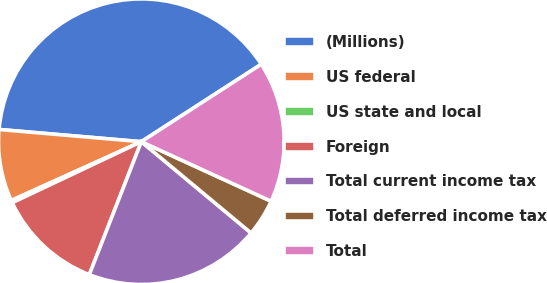<chart> <loc_0><loc_0><loc_500><loc_500><pie_chart><fcel>(Millions)<fcel>US federal<fcel>US state and local<fcel>Foreign<fcel>Total current income tax<fcel>Total deferred income tax<fcel>Total<nl><fcel>39.51%<fcel>8.12%<fcel>0.27%<fcel>12.04%<fcel>19.89%<fcel>4.2%<fcel>15.97%<nl></chart> 